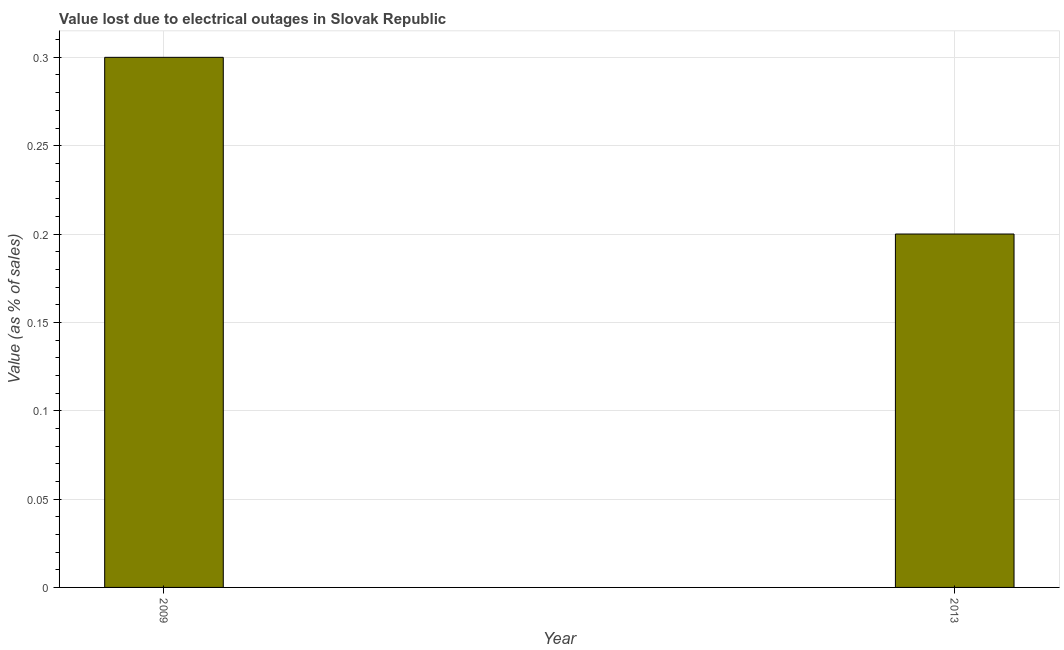What is the title of the graph?
Offer a terse response. Value lost due to electrical outages in Slovak Republic. What is the label or title of the X-axis?
Your response must be concise. Year. What is the label or title of the Y-axis?
Offer a very short reply. Value (as % of sales). Across all years, what is the minimum value lost due to electrical outages?
Provide a short and direct response. 0.2. In which year was the value lost due to electrical outages maximum?
Your response must be concise. 2009. In which year was the value lost due to electrical outages minimum?
Ensure brevity in your answer.  2013. What is the sum of the value lost due to electrical outages?
Make the answer very short. 0.5. Do a majority of the years between 2009 and 2013 (inclusive) have value lost due to electrical outages greater than 0.15 %?
Your response must be concise. Yes. In how many years, is the value lost due to electrical outages greater than the average value lost due to electrical outages taken over all years?
Ensure brevity in your answer.  1. Are all the bars in the graph horizontal?
Your answer should be compact. No. How many years are there in the graph?
Your response must be concise. 2. What is the ratio of the Value (as % of sales) in 2009 to that in 2013?
Offer a terse response. 1.5. 